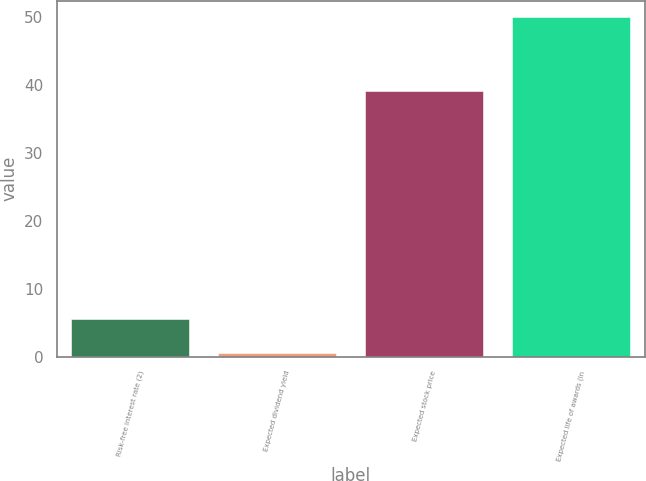Convert chart. <chart><loc_0><loc_0><loc_500><loc_500><bar_chart><fcel>Risk-free interest rate (2)<fcel>Expected dividend yield<fcel>Expected stock price<fcel>Expected life of awards (in<nl><fcel>5.54<fcel>0.6<fcel>39.2<fcel>50<nl></chart> 